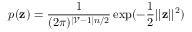<formula> <loc_0><loc_0><loc_500><loc_500>p ( z ) = \frac { 1 } { ( 2 \pi ) ^ { | \mathcal { V } - 1 | n / 2 } } \exp ( - \frac { 1 } { 2 } | | z | | ^ { 2 } )</formula> 